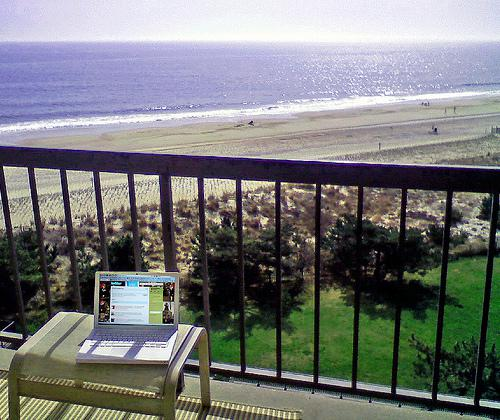Question: when is this picture taken?
Choices:
A. At night.
B. During the day.
C. Early morning.
D. New Year's eve.
Answer with the letter. Answer: B Question: where is the stool?
Choices:
A. To the right.
B. On the table.
C. In a pile.
D. To the left.
Answer with the letter. Answer: D 